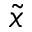<formula> <loc_0><loc_0><loc_500><loc_500>\widetilde { x }</formula> 